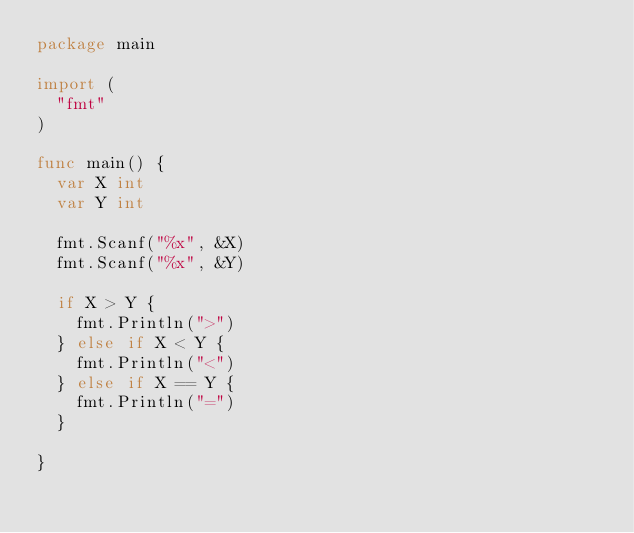Convert code to text. <code><loc_0><loc_0><loc_500><loc_500><_Go_>package main

import (
	"fmt"
)

func main() {
	var X int
	var Y int

	fmt.Scanf("%x", &X)
	fmt.Scanf("%x", &Y)

	if X > Y {
		fmt.Println(">")
	} else if X < Y {
		fmt.Println("<")
	} else if X == Y {
		fmt.Println("=")
	}

}
</code> 